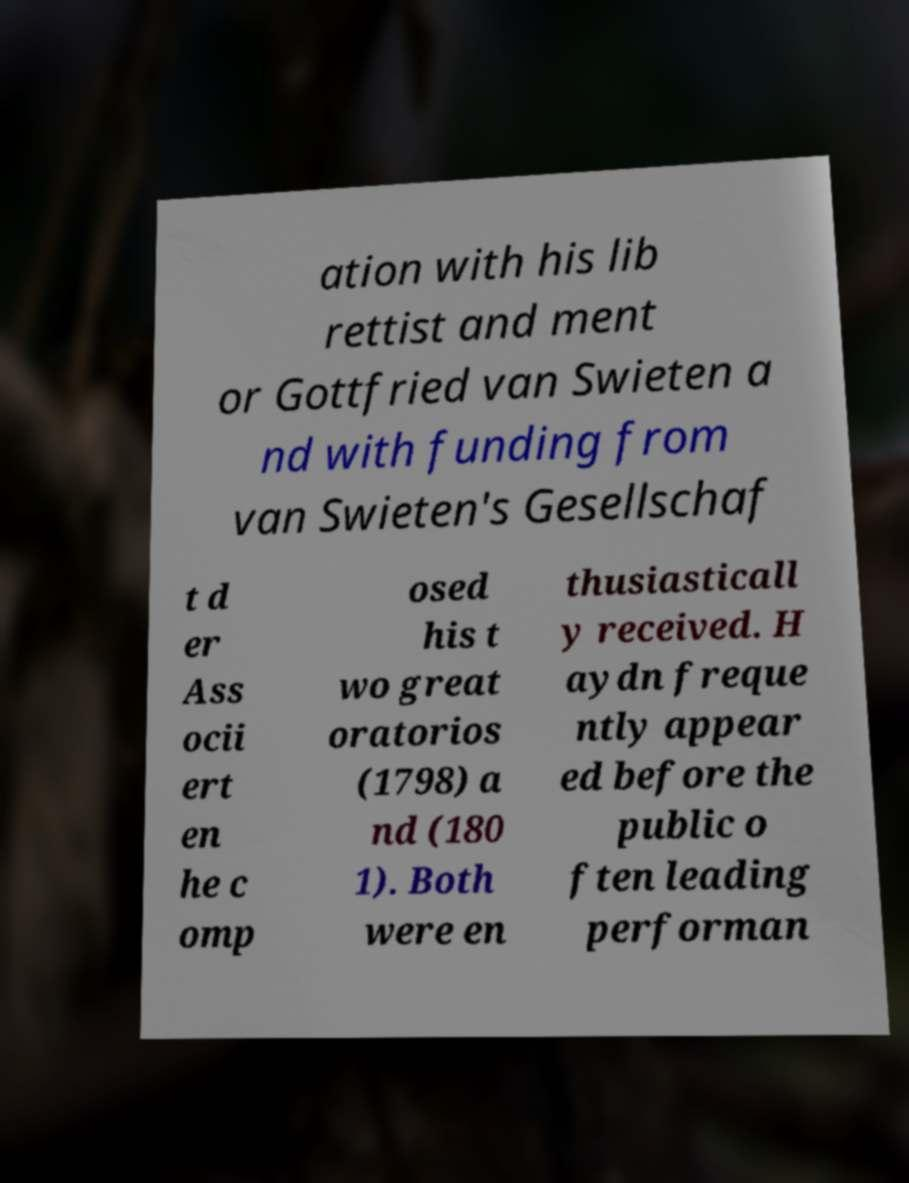There's text embedded in this image that I need extracted. Can you transcribe it verbatim? ation with his lib rettist and ment or Gottfried van Swieten a nd with funding from van Swieten's Gesellschaf t d er Ass ocii ert en he c omp osed his t wo great oratorios (1798) a nd (180 1). Both were en thusiasticall y received. H aydn freque ntly appear ed before the public o ften leading performan 